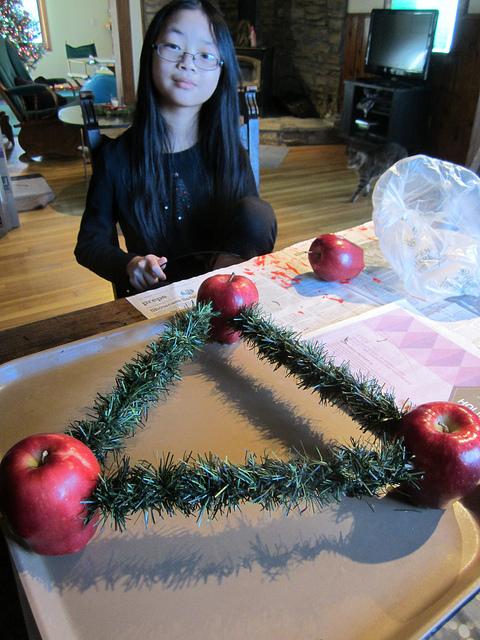How many apples in the triangle?
Concise answer only. 3. Does the human looks like asian?
Quick response, please. Yes. What holiday is near?
Answer briefly. Christmas. 